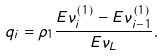<formula> <loc_0><loc_0><loc_500><loc_500>q _ { i } = \rho _ { 1 } \frac { E \nu _ { i } ^ { ( 1 ) } - E \nu _ { i - 1 } ^ { ( 1 ) } } { E \nu _ { L } } .</formula> 